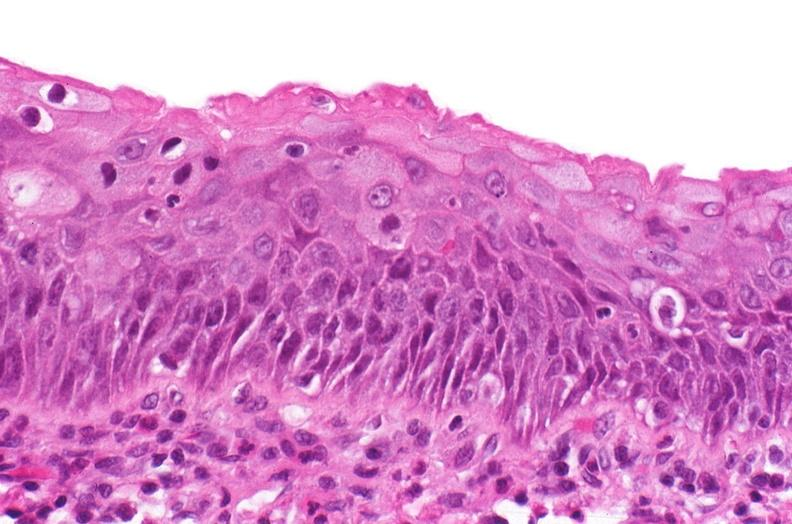why does this image show renal pelvis, squamous metaplasia?
Answer the question using a single word or phrase. Due to chronic urolithiasis 